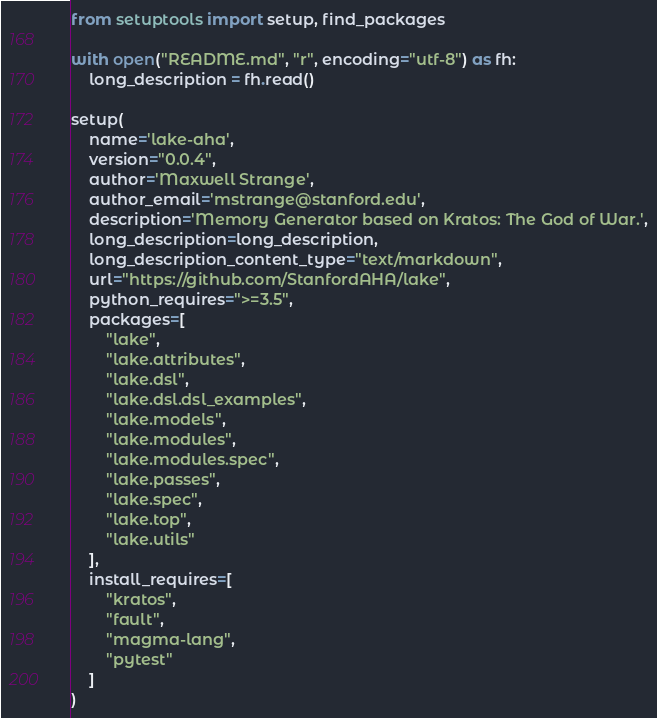Convert code to text. <code><loc_0><loc_0><loc_500><loc_500><_Python_>from setuptools import setup, find_packages

with open("README.md", "r", encoding="utf-8") as fh:
    long_description = fh.read()

setup(
    name='lake-aha',
    version="0.0.4",
    author='Maxwell Strange',
    author_email='mstrange@stanford.edu',
    description='Memory Generator based on Kratos: The God of War.',
    long_description=long_description,
    long_description_content_type="text/markdown",
    url="https://github.com/StanfordAHA/lake",
    python_requires=">=3.5",
    packages=[
        "lake",
        "lake.attributes",
        "lake.dsl",
        "lake.dsl.dsl_examples",
        "lake.models",
        "lake.modules",
        "lake.modules.spec",
        "lake.passes",
        "lake.spec",
        "lake.top",
        "lake.utils"
    ],
    install_requires=[
        "kratos",
        "fault",
        "magma-lang",
        "pytest"
    ]
)
</code> 